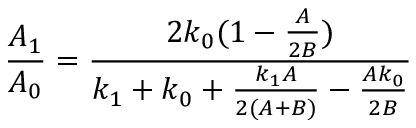Convert formula to latex. <formula><loc_0><loc_0><loc_500><loc_500>\frac { A _ { 1 } } { A _ { 0 } } = \frac { 2 k _ { 0 } ( 1 - \frac { A } { 2 B } ) } { k _ { 1 } + k _ { 0 } + \frac { k _ { 1 } A } { 2 ( A + B ) } - \frac { A k _ { 0 } } { 2 B } }</formula> 